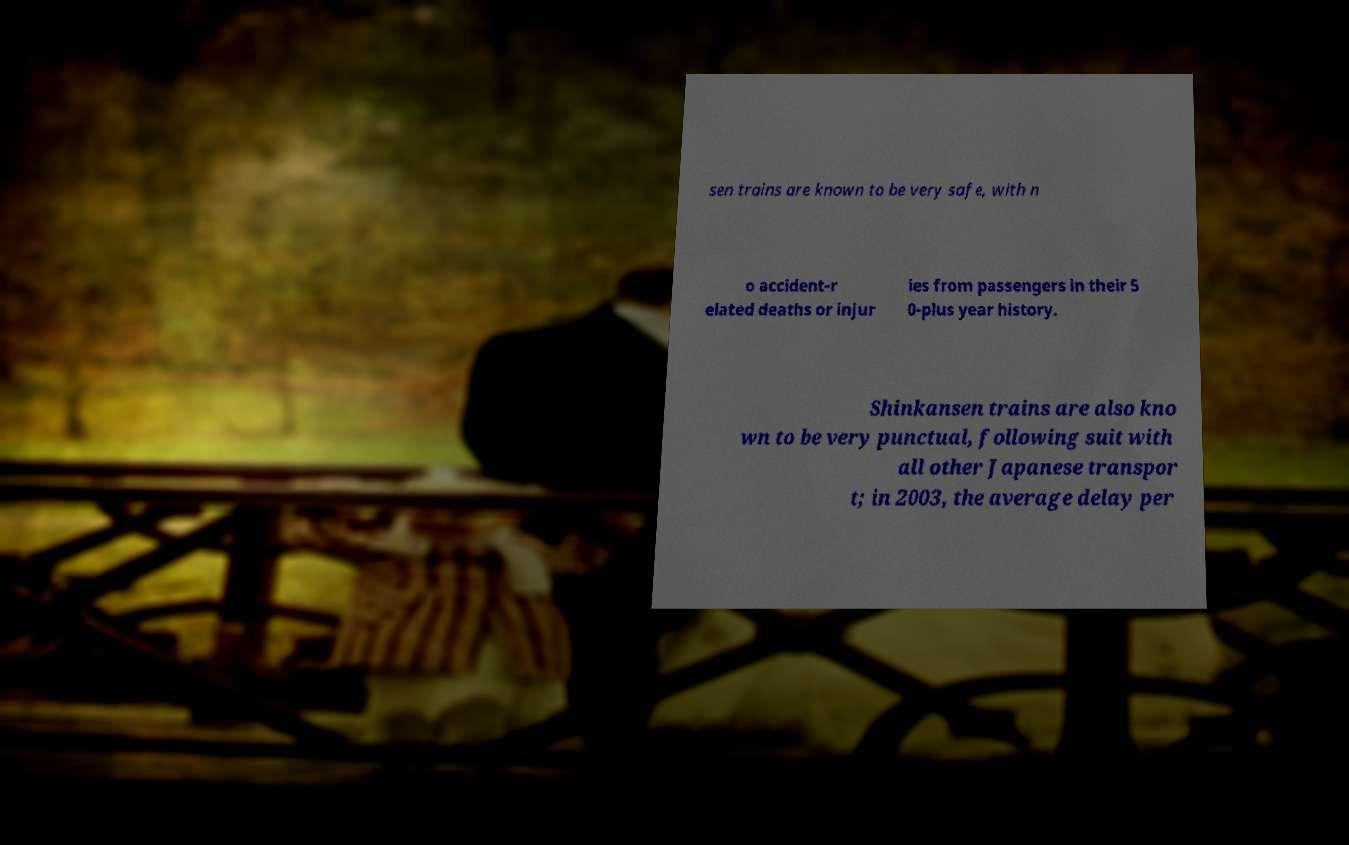Could you assist in decoding the text presented in this image and type it out clearly? sen trains are known to be very safe, with n o accident-r elated deaths or injur ies from passengers in their 5 0-plus year history. Shinkansen trains are also kno wn to be very punctual, following suit with all other Japanese transpor t; in 2003, the average delay per 